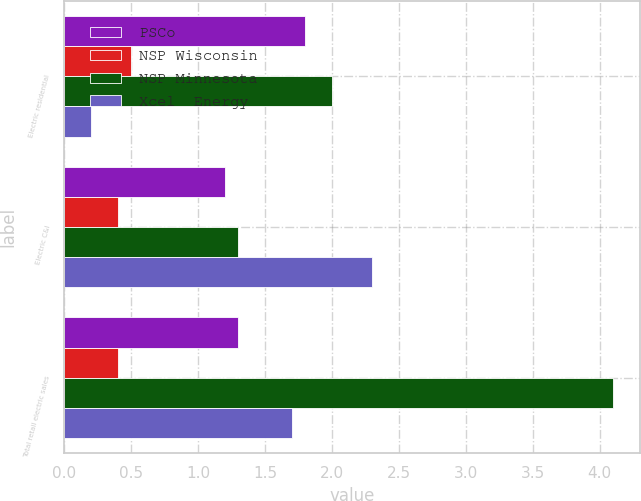<chart> <loc_0><loc_0><loc_500><loc_500><stacked_bar_chart><ecel><fcel>Electric residential<fcel>Electric C&I<fcel>Total retail electric sales<nl><fcel>PSCo<fcel>1.8<fcel>1.2<fcel>1.3<nl><fcel>NSP Wisconsin<fcel>0.5<fcel>0.4<fcel>0.4<nl><fcel>NSP Minnesota<fcel>2<fcel>1.3<fcel>4.1<nl><fcel>Xcel  Energy<fcel>0.2<fcel>2.3<fcel>1.7<nl></chart> 